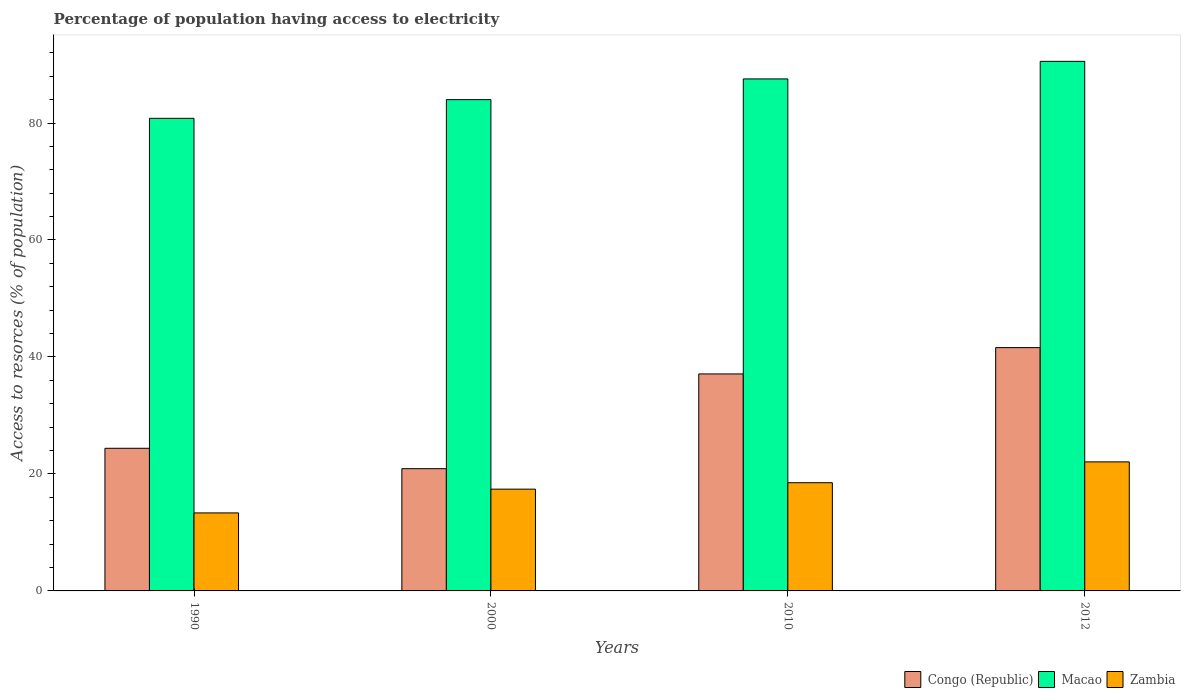How many groups of bars are there?
Your answer should be very brief. 4. Are the number of bars per tick equal to the number of legend labels?
Offer a very short reply. Yes. What is the label of the 4th group of bars from the left?
Your answer should be very brief. 2012. What is the percentage of population having access to electricity in Congo (Republic) in 2000?
Provide a short and direct response. 20.9. Across all years, what is the maximum percentage of population having access to electricity in Zambia?
Give a very brief answer. 22.06. Across all years, what is the minimum percentage of population having access to electricity in Macao?
Keep it short and to the point. 80.8. In which year was the percentage of population having access to electricity in Congo (Republic) maximum?
Offer a terse response. 2012. In which year was the percentage of population having access to electricity in Congo (Republic) minimum?
Provide a short and direct response. 2000. What is the total percentage of population having access to electricity in Macao in the graph?
Ensure brevity in your answer.  342.89. What is the difference between the percentage of population having access to electricity in Zambia in 2000 and that in 2012?
Your answer should be compact. -4.66. What is the difference between the percentage of population having access to electricity in Macao in 2000 and the percentage of population having access to electricity in Congo (Republic) in 2010?
Keep it short and to the point. 46.9. What is the average percentage of population having access to electricity in Macao per year?
Give a very brief answer. 85.72. In the year 2012, what is the difference between the percentage of population having access to electricity in Macao and percentage of population having access to electricity in Congo (Republic)?
Your answer should be compact. 48.94. In how many years, is the percentage of population having access to electricity in Macao greater than 8 %?
Ensure brevity in your answer.  4. What is the ratio of the percentage of population having access to electricity in Congo (Republic) in 1990 to that in 2000?
Offer a terse response. 1.17. Is the percentage of population having access to electricity in Congo (Republic) in 1990 less than that in 2012?
Offer a terse response. Yes. Is the difference between the percentage of population having access to electricity in Macao in 2010 and 2012 greater than the difference between the percentage of population having access to electricity in Congo (Republic) in 2010 and 2012?
Your response must be concise. Yes. What is the difference between the highest and the second highest percentage of population having access to electricity in Zambia?
Give a very brief answer. 3.56. What is the difference between the highest and the lowest percentage of population having access to electricity in Congo (Republic)?
Your answer should be compact. 20.7. In how many years, is the percentage of population having access to electricity in Zambia greater than the average percentage of population having access to electricity in Zambia taken over all years?
Provide a short and direct response. 2. What does the 2nd bar from the left in 1990 represents?
Keep it short and to the point. Macao. What does the 1st bar from the right in 2000 represents?
Make the answer very short. Zambia. Is it the case that in every year, the sum of the percentage of population having access to electricity in Zambia and percentage of population having access to electricity in Congo (Republic) is greater than the percentage of population having access to electricity in Macao?
Offer a very short reply. No. How many bars are there?
Your answer should be very brief. 12. Are all the bars in the graph horizontal?
Provide a short and direct response. No. Are the values on the major ticks of Y-axis written in scientific E-notation?
Provide a succinct answer. No. Does the graph contain any zero values?
Make the answer very short. No. What is the title of the graph?
Offer a very short reply. Percentage of population having access to electricity. Does "Nigeria" appear as one of the legend labels in the graph?
Provide a succinct answer. No. What is the label or title of the X-axis?
Ensure brevity in your answer.  Years. What is the label or title of the Y-axis?
Offer a very short reply. Access to resorces (% of population). What is the Access to resorces (% of population) in Congo (Republic) in 1990?
Offer a terse response. 24.39. What is the Access to resorces (% of population) of Macao in 1990?
Provide a succinct answer. 80.8. What is the Access to resorces (% of population) of Zambia in 1990?
Provide a short and direct response. 13.34. What is the Access to resorces (% of population) of Congo (Republic) in 2000?
Your answer should be very brief. 20.9. What is the Access to resorces (% of population) of Zambia in 2000?
Ensure brevity in your answer.  17.4. What is the Access to resorces (% of population) in Congo (Republic) in 2010?
Ensure brevity in your answer.  37.1. What is the Access to resorces (% of population) in Macao in 2010?
Make the answer very short. 87.54. What is the Access to resorces (% of population) in Congo (Republic) in 2012?
Ensure brevity in your answer.  41.6. What is the Access to resorces (% of population) in Macao in 2012?
Your answer should be very brief. 90.54. What is the Access to resorces (% of population) of Zambia in 2012?
Give a very brief answer. 22.06. Across all years, what is the maximum Access to resorces (% of population) of Congo (Republic)?
Give a very brief answer. 41.6. Across all years, what is the maximum Access to resorces (% of population) of Macao?
Ensure brevity in your answer.  90.54. Across all years, what is the maximum Access to resorces (% of population) in Zambia?
Your answer should be compact. 22.06. Across all years, what is the minimum Access to resorces (% of population) in Congo (Republic)?
Your response must be concise. 20.9. Across all years, what is the minimum Access to resorces (% of population) in Macao?
Make the answer very short. 80.8. Across all years, what is the minimum Access to resorces (% of population) in Zambia?
Keep it short and to the point. 13.34. What is the total Access to resorces (% of population) of Congo (Republic) in the graph?
Keep it short and to the point. 123.99. What is the total Access to resorces (% of population) in Macao in the graph?
Your answer should be compact. 342.89. What is the total Access to resorces (% of population) of Zambia in the graph?
Provide a short and direct response. 71.3. What is the difference between the Access to resorces (% of population) in Congo (Republic) in 1990 and that in 2000?
Keep it short and to the point. 3.49. What is the difference between the Access to resorces (% of population) of Macao in 1990 and that in 2000?
Offer a very short reply. -3.2. What is the difference between the Access to resorces (% of population) in Zambia in 1990 and that in 2000?
Offer a very short reply. -4.06. What is the difference between the Access to resorces (% of population) of Congo (Republic) in 1990 and that in 2010?
Provide a short and direct response. -12.71. What is the difference between the Access to resorces (% of population) of Macao in 1990 and that in 2010?
Offer a terse response. -6.74. What is the difference between the Access to resorces (% of population) of Zambia in 1990 and that in 2010?
Make the answer very short. -5.16. What is the difference between the Access to resorces (% of population) in Congo (Republic) in 1990 and that in 2012?
Your answer should be compact. -17.21. What is the difference between the Access to resorces (% of population) in Macao in 1990 and that in 2012?
Your answer should be compact. -9.74. What is the difference between the Access to resorces (% of population) in Zambia in 1990 and that in 2012?
Provide a succinct answer. -8.72. What is the difference between the Access to resorces (% of population) of Congo (Republic) in 2000 and that in 2010?
Provide a succinct answer. -16.2. What is the difference between the Access to resorces (% of population) of Macao in 2000 and that in 2010?
Provide a short and direct response. -3.54. What is the difference between the Access to resorces (% of population) of Congo (Republic) in 2000 and that in 2012?
Provide a succinct answer. -20.7. What is the difference between the Access to resorces (% of population) in Macao in 2000 and that in 2012?
Keep it short and to the point. -6.54. What is the difference between the Access to resorces (% of population) in Zambia in 2000 and that in 2012?
Your response must be concise. -4.66. What is the difference between the Access to resorces (% of population) in Macao in 2010 and that in 2012?
Give a very brief answer. -3. What is the difference between the Access to resorces (% of population) in Zambia in 2010 and that in 2012?
Your answer should be compact. -3.56. What is the difference between the Access to resorces (% of population) in Congo (Republic) in 1990 and the Access to resorces (% of population) in Macao in 2000?
Offer a very short reply. -59.61. What is the difference between the Access to resorces (% of population) in Congo (Republic) in 1990 and the Access to resorces (% of population) in Zambia in 2000?
Provide a succinct answer. 6.99. What is the difference between the Access to resorces (% of population) of Macao in 1990 and the Access to resorces (% of population) of Zambia in 2000?
Your response must be concise. 63.4. What is the difference between the Access to resorces (% of population) of Congo (Republic) in 1990 and the Access to resorces (% of population) of Macao in 2010?
Offer a terse response. -63.15. What is the difference between the Access to resorces (% of population) in Congo (Republic) in 1990 and the Access to resorces (% of population) in Zambia in 2010?
Give a very brief answer. 5.89. What is the difference between the Access to resorces (% of population) in Macao in 1990 and the Access to resorces (% of population) in Zambia in 2010?
Make the answer very short. 62.3. What is the difference between the Access to resorces (% of population) in Congo (Republic) in 1990 and the Access to resorces (% of population) in Macao in 2012?
Your answer should be very brief. -66.15. What is the difference between the Access to resorces (% of population) in Congo (Republic) in 1990 and the Access to resorces (% of population) in Zambia in 2012?
Your response must be concise. 2.33. What is the difference between the Access to resorces (% of population) in Macao in 1990 and the Access to resorces (% of population) in Zambia in 2012?
Your response must be concise. 58.74. What is the difference between the Access to resorces (% of population) in Congo (Republic) in 2000 and the Access to resorces (% of population) in Macao in 2010?
Keep it short and to the point. -66.64. What is the difference between the Access to resorces (% of population) in Congo (Republic) in 2000 and the Access to resorces (% of population) in Zambia in 2010?
Offer a very short reply. 2.4. What is the difference between the Access to resorces (% of population) of Macao in 2000 and the Access to resorces (% of population) of Zambia in 2010?
Make the answer very short. 65.5. What is the difference between the Access to resorces (% of population) in Congo (Republic) in 2000 and the Access to resorces (% of population) in Macao in 2012?
Your response must be concise. -69.64. What is the difference between the Access to resorces (% of population) in Congo (Republic) in 2000 and the Access to resorces (% of population) in Zambia in 2012?
Provide a succinct answer. -1.16. What is the difference between the Access to resorces (% of population) in Macao in 2000 and the Access to resorces (% of population) in Zambia in 2012?
Offer a very short reply. 61.94. What is the difference between the Access to resorces (% of population) in Congo (Republic) in 2010 and the Access to resorces (% of population) in Macao in 2012?
Offer a terse response. -53.44. What is the difference between the Access to resorces (% of population) in Congo (Republic) in 2010 and the Access to resorces (% of population) in Zambia in 2012?
Provide a succinct answer. 15.04. What is the difference between the Access to resorces (% of population) in Macao in 2010 and the Access to resorces (% of population) in Zambia in 2012?
Make the answer very short. 65.48. What is the average Access to resorces (% of population) in Congo (Republic) per year?
Keep it short and to the point. 31. What is the average Access to resorces (% of population) in Macao per year?
Offer a very short reply. 85.72. What is the average Access to resorces (% of population) in Zambia per year?
Your answer should be very brief. 17.83. In the year 1990, what is the difference between the Access to resorces (% of population) in Congo (Republic) and Access to resorces (% of population) in Macao?
Keep it short and to the point. -56.42. In the year 1990, what is the difference between the Access to resorces (% of population) in Congo (Republic) and Access to resorces (% of population) in Zambia?
Provide a short and direct response. 11.05. In the year 1990, what is the difference between the Access to resorces (% of population) in Macao and Access to resorces (% of population) in Zambia?
Ensure brevity in your answer.  67.47. In the year 2000, what is the difference between the Access to resorces (% of population) of Congo (Republic) and Access to resorces (% of population) of Macao?
Your answer should be compact. -63.1. In the year 2000, what is the difference between the Access to resorces (% of population) of Macao and Access to resorces (% of population) of Zambia?
Your response must be concise. 66.6. In the year 2010, what is the difference between the Access to resorces (% of population) of Congo (Republic) and Access to resorces (% of population) of Macao?
Your answer should be compact. -50.44. In the year 2010, what is the difference between the Access to resorces (% of population) of Macao and Access to resorces (% of population) of Zambia?
Your answer should be compact. 69.04. In the year 2012, what is the difference between the Access to resorces (% of population) in Congo (Republic) and Access to resorces (% of population) in Macao?
Make the answer very short. -48.94. In the year 2012, what is the difference between the Access to resorces (% of population) in Congo (Republic) and Access to resorces (% of population) in Zambia?
Offer a terse response. 19.54. In the year 2012, what is the difference between the Access to resorces (% of population) of Macao and Access to resorces (% of population) of Zambia?
Give a very brief answer. 68.48. What is the ratio of the Access to resorces (% of population) of Congo (Republic) in 1990 to that in 2000?
Offer a terse response. 1.17. What is the ratio of the Access to resorces (% of population) in Macao in 1990 to that in 2000?
Offer a terse response. 0.96. What is the ratio of the Access to resorces (% of population) in Zambia in 1990 to that in 2000?
Your answer should be compact. 0.77. What is the ratio of the Access to resorces (% of population) in Congo (Republic) in 1990 to that in 2010?
Provide a succinct answer. 0.66. What is the ratio of the Access to resorces (% of population) of Macao in 1990 to that in 2010?
Offer a very short reply. 0.92. What is the ratio of the Access to resorces (% of population) in Zambia in 1990 to that in 2010?
Provide a short and direct response. 0.72. What is the ratio of the Access to resorces (% of population) of Congo (Republic) in 1990 to that in 2012?
Ensure brevity in your answer.  0.59. What is the ratio of the Access to resorces (% of population) in Macao in 1990 to that in 2012?
Give a very brief answer. 0.89. What is the ratio of the Access to resorces (% of population) of Zambia in 1990 to that in 2012?
Provide a short and direct response. 0.6. What is the ratio of the Access to resorces (% of population) of Congo (Republic) in 2000 to that in 2010?
Ensure brevity in your answer.  0.56. What is the ratio of the Access to resorces (% of population) of Macao in 2000 to that in 2010?
Make the answer very short. 0.96. What is the ratio of the Access to resorces (% of population) of Zambia in 2000 to that in 2010?
Keep it short and to the point. 0.94. What is the ratio of the Access to resorces (% of population) in Congo (Republic) in 2000 to that in 2012?
Provide a short and direct response. 0.5. What is the ratio of the Access to resorces (% of population) in Macao in 2000 to that in 2012?
Make the answer very short. 0.93. What is the ratio of the Access to resorces (% of population) of Zambia in 2000 to that in 2012?
Keep it short and to the point. 0.79. What is the ratio of the Access to resorces (% of population) in Congo (Republic) in 2010 to that in 2012?
Your answer should be compact. 0.89. What is the ratio of the Access to resorces (% of population) of Macao in 2010 to that in 2012?
Ensure brevity in your answer.  0.97. What is the ratio of the Access to resorces (% of population) in Zambia in 2010 to that in 2012?
Give a very brief answer. 0.84. What is the difference between the highest and the second highest Access to resorces (% of population) in Congo (Republic)?
Your response must be concise. 4.5. What is the difference between the highest and the second highest Access to resorces (% of population) in Macao?
Provide a short and direct response. 3. What is the difference between the highest and the second highest Access to resorces (% of population) in Zambia?
Provide a succinct answer. 3.56. What is the difference between the highest and the lowest Access to resorces (% of population) of Congo (Republic)?
Keep it short and to the point. 20.7. What is the difference between the highest and the lowest Access to resorces (% of population) of Macao?
Offer a terse response. 9.74. What is the difference between the highest and the lowest Access to resorces (% of population) in Zambia?
Give a very brief answer. 8.72. 